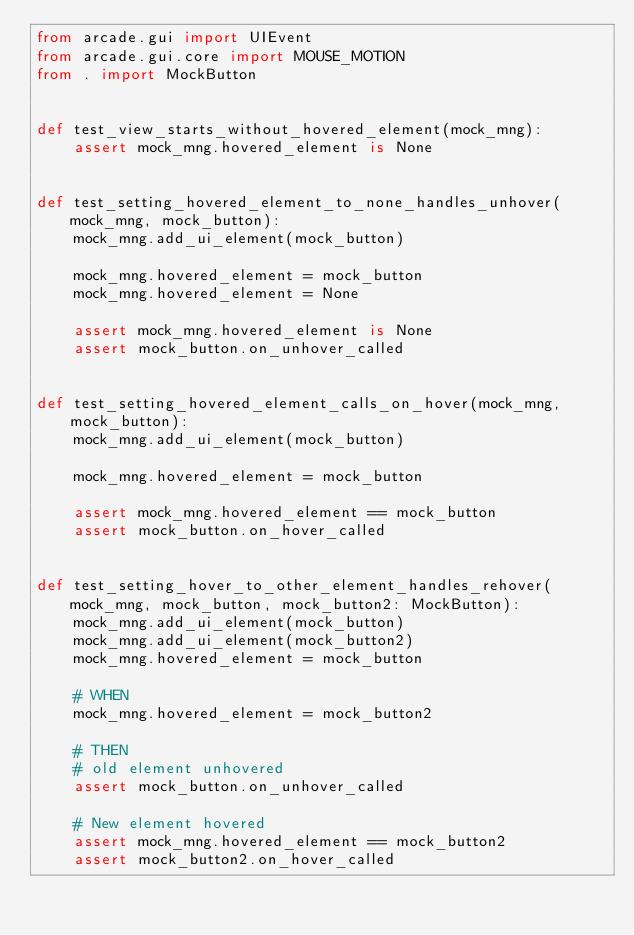Convert code to text. <code><loc_0><loc_0><loc_500><loc_500><_Python_>from arcade.gui import UIEvent
from arcade.gui.core import MOUSE_MOTION
from . import MockButton


def test_view_starts_without_hovered_element(mock_mng):
    assert mock_mng.hovered_element is None


def test_setting_hovered_element_to_none_handles_unhover(mock_mng, mock_button):
    mock_mng.add_ui_element(mock_button)

    mock_mng.hovered_element = mock_button
    mock_mng.hovered_element = None

    assert mock_mng.hovered_element is None
    assert mock_button.on_unhover_called


def test_setting_hovered_element_calls_on_hover(mock_mng, mock_button):
    mock_mng.add_ui_element(mock_button)

    mock_mng.hovered_element = mock_button

    assert mock_mng.hovered_element == mock_button
    assert mock_button.on_hover_called


def test_setting_hover_to_other_element_handles_rehover(mock_mng, mock_button, mock_button2: MockButton):
    mock_mng.add_ui_element(mock_button)
    mock_mng.add_ui_element(mock_button2)
    mock_mng.hovered_element = mock_button

    # WHEN
    mock_mng.hovered_element = mock_button2

    # THEN
    # old element unhovered
    assert mock_button.on_unhover_called

    # New element hovered
    assert mock_mng.hovered_element == mock_button2
    assert mock_button2.on_hover_called</code> 